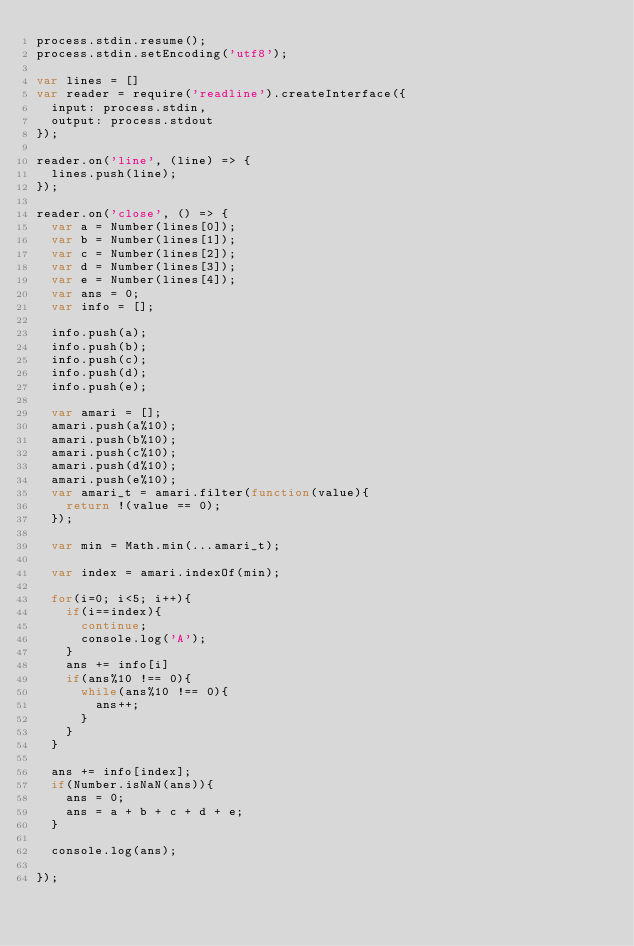<code> <loc_0><loc_0><loc_500><loc_500><_JavaScript_>process.stdin.resume();
process.stdin.setEncoding('utf8');

var lines = []
var reader = require('readline').createInterface({
  input: process.stdin,
  output: process.stdout
});

reader.on('line', (line) => {
  lines.push(line);
});

reader.on('close', () => {
  var a = Number(lines[0]);
  var b = Number(lines[1]);
  var c = Number(lines[2]);
  var d = Number(lines[3]);
  var e = Number(lines[4]);
  var ans = 0;
  var info = [];
 
  info.push(a);
  info.push(b);
  info.push(c);
  info.push(d);
  info.push(e);
 
  var amari = [];
  amari.push(a%10);
  amari.push(b%10);
  amari.push(c%10);
  amari.push(d%10);
  amari.push(e%10);
  var amari_t = amari.filter(function(value){
    return !(value == 0);
  });
 
  var min = Math.min(...amari_t);
 
  var index = amari.indexOf(min);
 
  for(i=0; i<5; i++){
    if(i==index){
      continue;
      console.log('A');
    }
    ans += info[i]
    if(ans%10 !== 0){
      while(ans%10 !== 0){
        ans++;
      }
    }
  }
 
  ans += info[index];
  if(Number.isNaN(ans)){
    ans = 0;
    ans = a + b + c + d + e;
  }
 
  console.log(ans);

});
</code> 